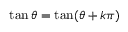Convert formula to latex. <formula><loc_0><loc_0><loc_500><loc_500>\tan \theta = \tan ( \theta + k \pi )</formula> 